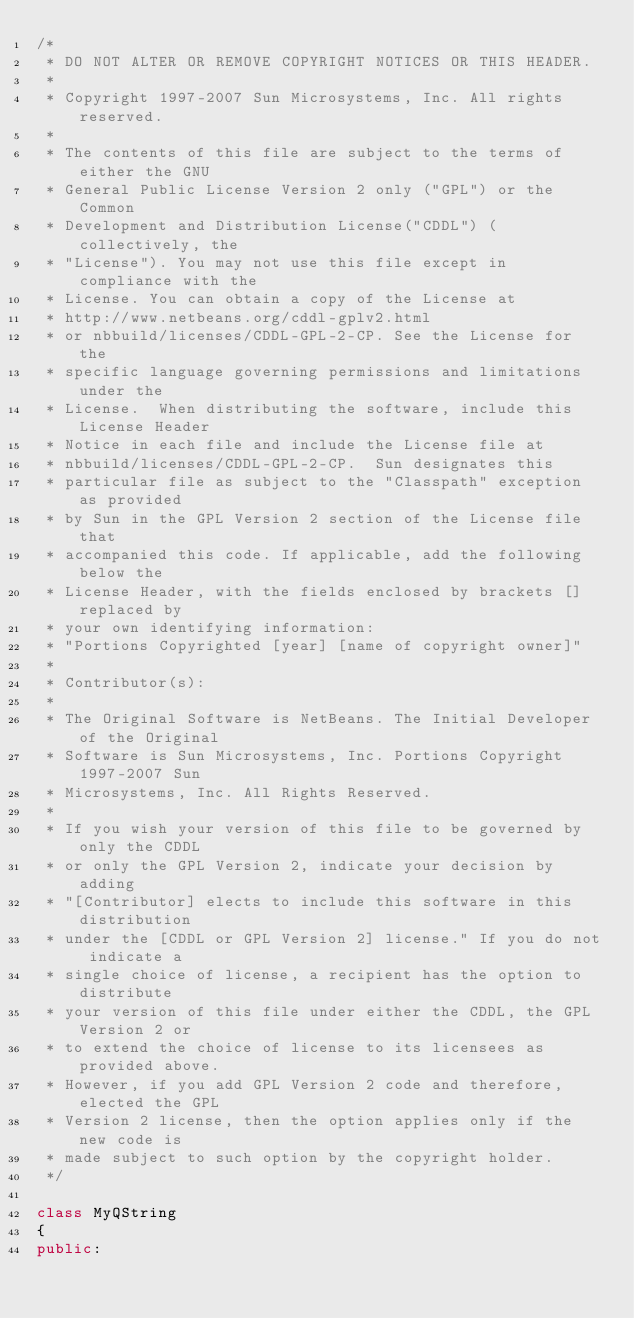<code> <loc_0><loc_0><loc_500><loc_500><_C++_>/*
 * DO NOT ALTER OR REMOVE COPYRIGHT NOTICES OR THIS HEADER.
 *
 * Copyright 1997-2007 Sun Microsystems, Inc. All rights reserved.
 *
 * The contents of this file are subject to the terms of either the GNU
 * General Public License Version 2 only ("GPL") or the Common
 * Development and Distribution License("CDDL") (collectively, the
 * "License"). You may not use this file except in compliance with the
 * License. You can obtain a copy of the License at
 * http://www.netbeans.org/cddl-gplv2.html
 * or nbbuild/licenses/CDDL-GPL-2-CP. See the License for the
 * specific language governing permissions and limitations under the
 * License.  When distributing the software, include this License Header
 * Notice in each file and include the License file at
 * nbbuild/licenses/CDDL-GPL-2-CP.  Sun designates this
 * particular file as subject to the "Classpath" exception as provided
 * by Sun in the GPL Version 2 section of the License file that
 * accompanied this code. If applicable, add the following below the
 * License Header, with the fields enclosed by brackets [] replaced by
 * your own identifying information:
 * "Portions Copyrighted [year] [name of copyright owner]"
 *
 * Contributor(s):
 *
 * The Original Software is NetBeans. The Initial Developer of the Original
 * Software is Sun Microsystems, Inc. Portions Copyright 1997-2007 Sun
 * Microsystems, Inc. All Rights Reserved.
 *
 * If you wish your version of this file to be governed by only the CDDL
 * or only the GPL Version 2, indicate your decision by adding
 * "[Contributor] elects to include this software in this distribution
 * under the [CDDL or GPL Version 2] license." If you do not indicate a
 * single choice of license, a recipient has the option to distribute
 * your version of this file under either the CDDL, the GPL Version 2 or
 * to extend the choice of license to its licensees as provided above.
 * However, if you add GPL Version 2 code and therefore, elected the GPL
 * Version 2 license, then the option applies only if the new code is
 * made subject to such option by the copyright holder.
 */

class MyQString
{
public:</code> 